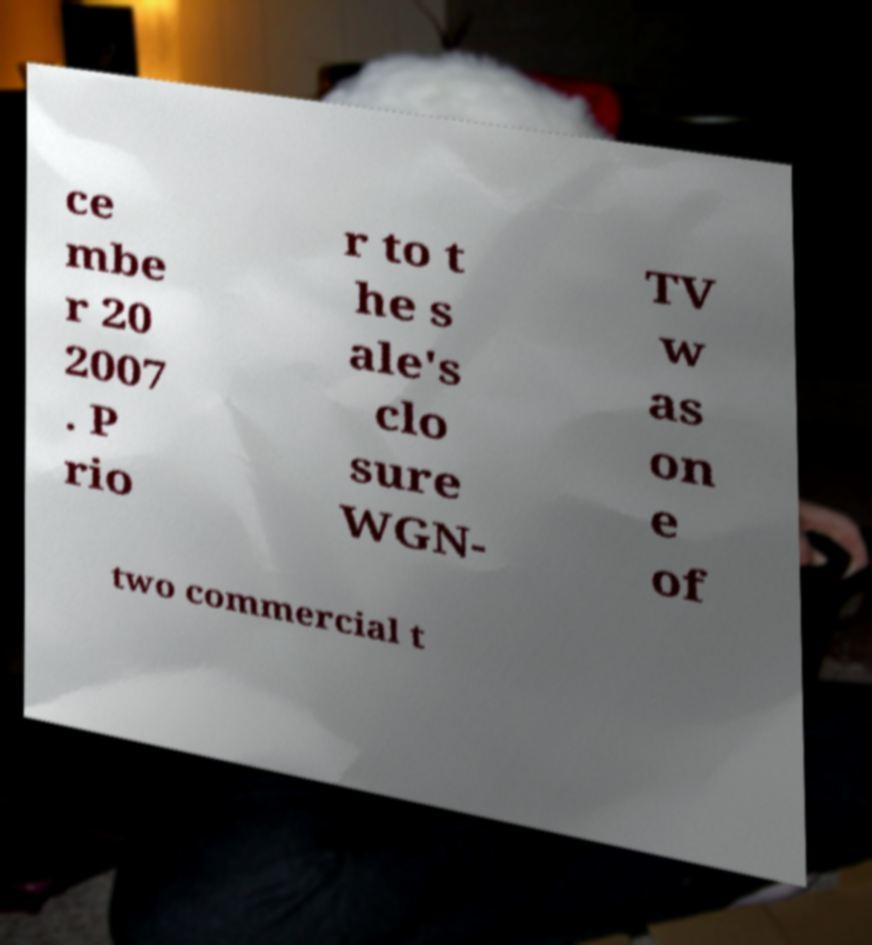I need the written content from this picture converted into text. Can you do that? ce mbe r 20 2007 . P rio r to t he s ale's clo sure WGN- TV w as on e of two commercial t 